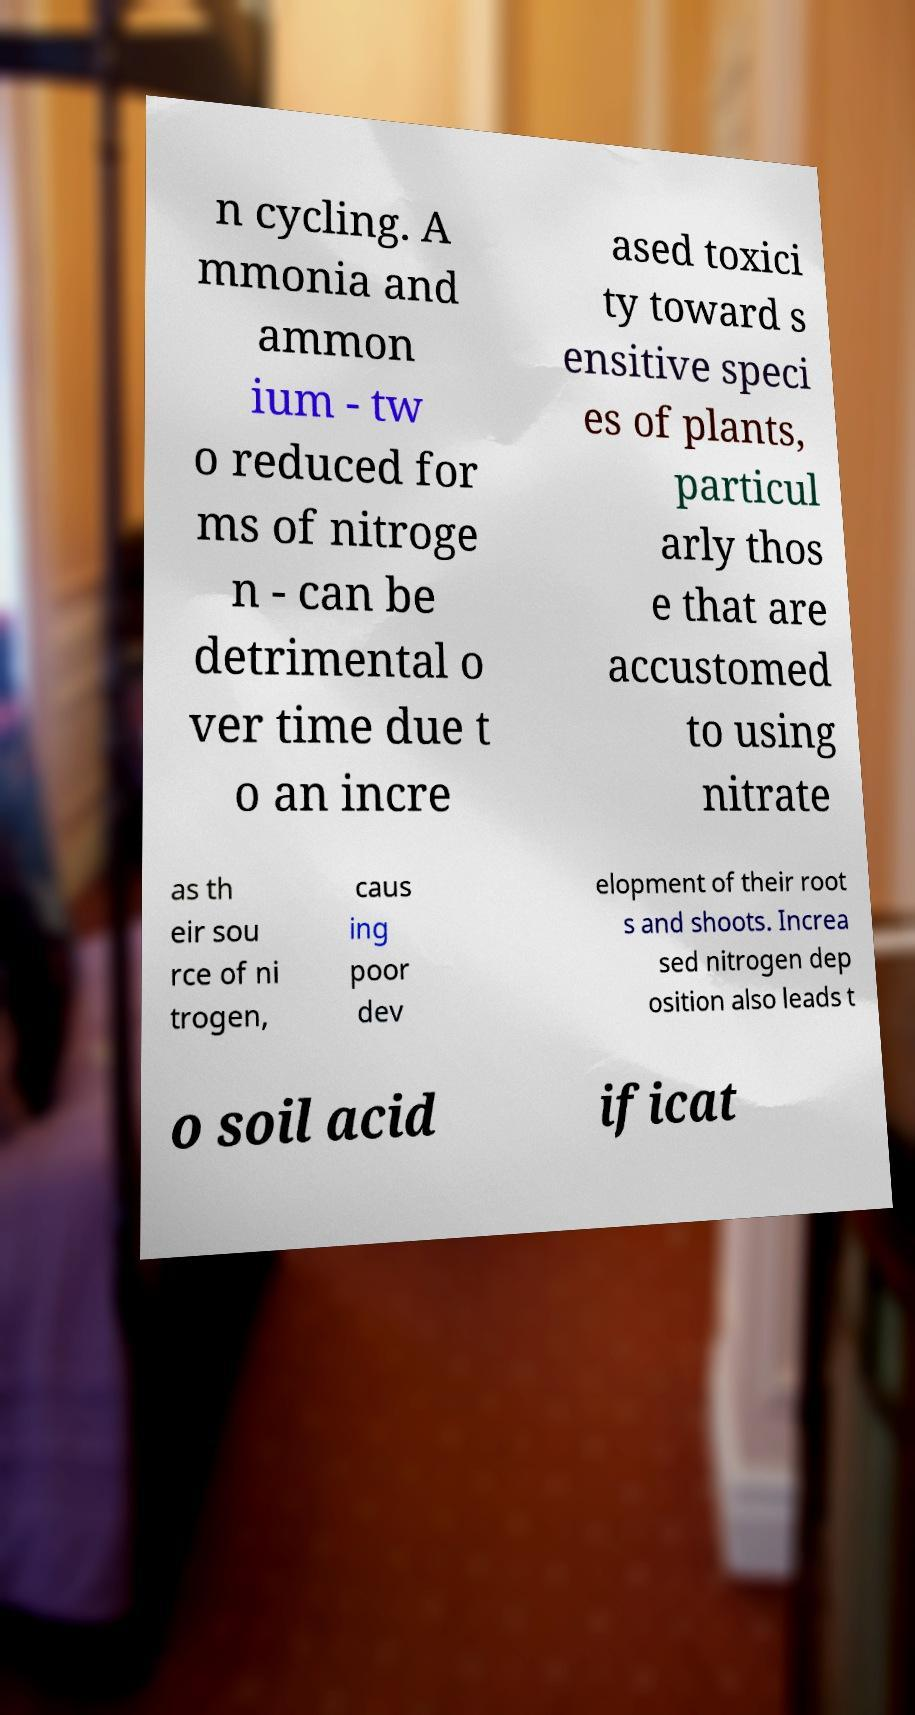Could you assist in decoding the text presented in this image and type it out clearly? n cycling. A mmonia and ammon ium - tw o reduced for ms of nitroge n - can be detrimental o ver time due t o an incre ased toxici ty toward s ensitive speci es of plants, particul arly thos e that are accustomed to using nitrate as th eir sou rce of ni trogen, caus ing poor dev elopment of their root s and shoots. Increa sed nitrogen dep osition also leads t o soil acid ificat 